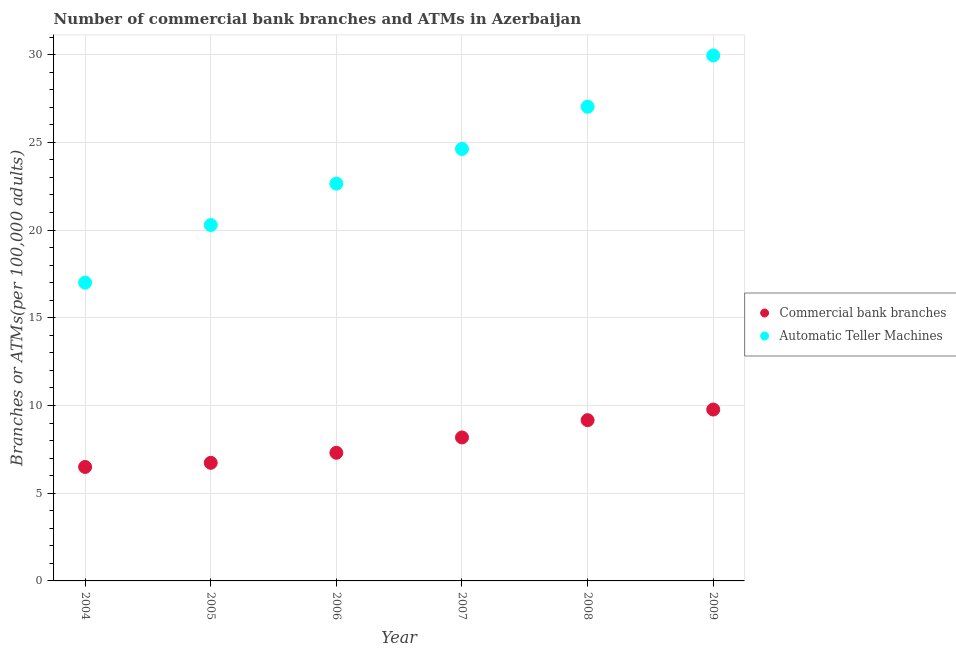Is the number of dotlines equal to the number of legend labels?
Ensure brevity in your answer.  Yes. What is the number of commercal bank branches in 2004?
Your response must be concise. 6.5. Across all years, what is the maximum number of atms?
Give a very brief answer. 29.95. Across all years, what is the minimum number of atms?
Your answer should be very brief. 17. In which year was the number of atms maximum?
Your answer should be compact. 2009. What is the total number of commercal bank branches in the graph?
Your answer should be very brief. 47.64. What is the difference between the number of commercal bank branches in 2005 and that in 2008?
Offer a very short reply. -2.43. What is the difference between the number of atms in 2008 and the number of commercal bank branches in 2004?
Keep it short and to the point. 20.53. What is the average number of atms per year?
Provide a short and direct response. 23.59. In the year 2009, what is the difference between the number of atms and number of commercal bank branches?
Give a very brief answer. 20.19. What is the ratio of the number of atms in 2008 to that in 2009?
Ensure brevity in your answer.  0.9. What is the difference between the highest and the second highest number of atms?
Your answer should be very brief. 2.92. What is the difference between the highest and the lowest number of commercal bank branches?
Give a very brief answer. 3.27. In how many years, is the number of commercal bank branches greater than the average number of commercal bank branches taken over all years?
Keep it short and to the point. 3. Is the sum of the number of atms in 2006 and 2008 greater than the maximum number of commercal bank branches across all years?
Keep it short and to the point. Yes. Does the number of atms monotonically increase over the years?
Provide a short and direct response. Yes. Is the number of commercal bank branches strictly greater than the number of atms over the years?
Keep it short and to the point. No. How many dotlines are there?
Offer a very short reply. 2. How many years are there in the graph?
Your answer should be very brief. 6. Are the values on the major ticks of Y-axis written in scientific E-notation?
Your response must be concise. No. Does the graph contain any zero values?
Provide a short and direct response. No. Does the graph contain grids?
Keep it short and to the point. Yes. Where does the legend appear in the graph?
Ensure brevity in your answer.  Center right. What is the title of the graph?
Provide a short and direct response. Number of commercial bank branches and ATMs in Azerbaijan. What is the label or title of the Y-axis?
Ensure brevity in your answer.  Branches or ATMs(per 100,0 adults). What is the Branches or ATMs(per 100,000 adults) in Commercial bank branches in 2004?
Your answer should be very brief. 6.5. What is the Branches or ATMs(per 100,000 adults) in Automatic Teller Machines in 2004?
Ensure brevity in your answer.  17. What is the Branches or ATMs(per 100,000 adults) of Commercial bank branches in 2005?
Offer a very short reply. 6.73. What is the Branches or ATMs(per 100,000 adults) of Automatic Teller Machines in 2005?
Provide a succinct answer. 20.29. What is the Branches or ATMs(per 100,000 adults) in Commercial bank branches in 2006?
Offer a terse response. 7.3. What is the Branches or ATMs(per 100,000 adults) in Automatic Teller Machines in 2006?
Your answer should be compact. 22.65. What is the Branches or ATMs(per 100,000 adults) of Commercial bank branches in 2007?
Provide a short and direct response. 8.18. What is the Branches or ATMs(per 100,000 adults) in Automatic Teller Machines in 2007?
Keep it short and to the point. 24.63. What is the Branches or ATMs(per 100,000 adults) in Commercial bank branches in 2008?
Your response must be concise. 9.16. What is the Branches or ATMs(per 100,000 adults) in Automatic Teller Machines in 2008?
Offer a terse response. 27.03. What is the Branches or ATMs(per 100,000 adults) of Commercial bank branches in 2009?
Offer a terse response. 9.77. What is the Branches or ATMs(per 100,000 adults) of Automatic Teller Machines in 2009?
Ensure brevity in your answer.  29.95. Across all years, what is the maximum Branches or ATMs(per 100,000 adults) of Commercial bank branches?
Keep it short and to the point. 9.77. Across all years, what is the maximum Branches or ATMs(per 100,000 adults) in Automatic Teller Machines?
Provide a succinct answer. 29.95. Across all years, what is the minimum Branches or ATMs(per 100,000 adults) of Commercial bank branches?
Keep it short and to the point. 6.5. Across all years, what is the minimum Branches or ATMs(per 100,000 adults) of Automatic Teller Machines?
Keep it short and to the point. 17. What is the total Branches or ATMs(per 100,000 adults) in Commercial bank branches in the graph?
Provide a short and direct response. 47.64. What is the total Branches or ATMs(per 100,000 adults) of Automatic Teller Machines in the graph?
Provide a short and direct response. 141.54. What is the difference between the Branches or ATMs(per 100,000 adults) of Commercial bank branches in 2004 and that in 2005?
Provide a succinct answer. -0.24. What is the difference between the Branches or ATMs(per 100,000 adults) in Automatic Teller Machines in 2004 and that in 2005?
Your response must be concise. -3.28. What is the difference between the Branches or ATMs(per 100,000 adults) in Commercial bank branches in 2004 and that in 2006?
Ensure brevity in your answer.  -0.81. What is the difference between the Branches or ATMs(per 100,000 adults) of Automatic Teller Machines in 2004 and that in 2006?
Offer a terse response. -5.65. What is the difference between the Branches or ATMs(per 100,000 adults) in Commercial bank branches in 2004 and that in 2007?
Your answer should be compact. -1.68. What is the difference between the Branches or ATMs(per 100,000 adults) in Automatic Teller Machines in 2004 and that in 2007?
Offer a terse response. -7.62. What is the difference between the Branches or ATMs(per 100,000 adults) in Commercial bank branches in 2004 and that in 2008?
Keep it short and to the point. -2.67. What is the difference between the Branches or ATMs(per 100,000 adults) of Automatic Teller Machines in 2004 and that in 2008?
Your answer should be compact. -10.03. What is the difference between the Branches or ATMs(per 100,000 adults) of Commercial bank branches in 2004 and that in 2009?
Offer a very short reply. -3.27. What is the difference between the Branches or ATMs(per 100,000 adults) in Automatic Teller Machines in 2004 and that in 2009?
Make the answer very short. -12.95. What is the difference between the Branches or ATMs(per 100,000 adults) in Commercial bank branches in 2005 and that in 2006?
Your response must be concise. -0.57. What is the difference between the Branches or ATMs(per 100,000 adults) of Automatic Teller Machines in 2005 and that in 2006?
Your response must be concise. -2.36. What is the difference between the Branches or ATMs(per 100,000 adults) of Commercial bank branches in 2005 and that in 2007?
Provide a succinct answer. -1.45. What is the difference between the Branches or ATMs(per 100,000 adults) of Automatic Teller Machines in 2005 and that in 2007?
Offer a very short reply. -4.34. What is the difference between the Branches or ATMs(per 100,000 adults) of Commercial bank branches in 2005 and that in 2008?
Ensure brevity in your answer.  -2.43. What is the difference between the Branches or ATMs(per 100,000 adults) of Automatic Teller Machines in 2005 and that in 2008?
Your response must be concise. -6.74. What is the difference between the Branches or ATMs(per 100,000 adults) of Commercial bank branches in 2005 and that in 2009?
Offer a very short reply. -3.04. What is the difference between the Branches or ATMs(per 100,000 adults) in Automatic Teller Machines in 2005 and that in 2009?
Offer a terse response. -9.67. What is the difference between the Branches or ATMs(per 100,000 adults) in Commercial bank branches in 2006 and that in 2007?
Your answer should be compact. -0.87. What is the difference between the Branches or ATMs(per 100,000 adults) in Automatic Teller Machines in 2006 and that in 2007?
Offer a terse response. -1.98. What is the difference between the Branches or ATMs(per 100,000 adults) in Commercial bank branches in 2006 and that in 2008?
Offer a very short reply. -1.86. What is the difference between the Branches or ATMs(per 100,000 adults) in Automatic Teller Machines in 2006 and that in 2008?
Give a very brief answer. -4.38. What is the difference between the Branches or ATMs(per 100,000 adults) of Commercial bank branches in 2006 and that in 2009?
Keep it short and to the point. -2.46. What is the difference between the Branches or ATMs(per 100,000 adults) in Automatic Teller Machines in 2006 and that in 2009?
Give a very brief answer. -7.31. What is the difference between the Branches or ATMs(per 100,000 adults) in Commercial bank branches in 2007 and that in 2008?
Provide a succinct answer. -0.98. What is the difference between the Branches or ATMs(per 100,000 adults) of Automatic Teller Machines in 2007 and that in 2008?
Keep it short and to the point. -2.41. What is the difference between the Branches or ATMs(per 100,000 adults) in Commercial bank branches in 2007 and that in 2009?
Provide a succinct answer. -1.59. What is the difference between the Branches or ATMs(per 100,000 adults) in Automatic Teller Machines in 2007 and that in 2009?
Your response must be concise. -5.33. What is the difference between the Branches or ATMs(per 100,000 adults) of Commercial bank branches in 2008 and that in 2009?
Provide a succinct answer. -0.6. What is the difference between the Branches or ATMs(per 100,000 adults) of Automatic Teller Machines in 2008 and that in 2009?
Offer a very short reply. -2.92. What is the difference between the Branches or ATMs(per 100,000 adults) in Commercial bank branches in 2004 and the Branches or ATMs(per 100,000 adults) in Automatic Teller Machines in 2005?
Provide a short and direct response. -13.79. What is the difference between the Branches or ATMs(per 100,000 adults) in Commercial bank branches in 2004 and the Branches or ATMs(per 100,000 adults) in Automatic Teller Machines in 2006?
Your answer should be very brief. -16.15. What is the difference between the Branches or ATMs(per 100,000 adults) in Commercial bank branches in 2004 and the Branches or ATMs(per 100,000 adults) in Automatic Teller Machines in 2007?
Offer a terse response. -18.13. What is the difference between the Branches or ATMs(per 100,000 adults) in Commercial bank branches in 2004 and the Branches or ATMs(per 100,000 adults) in Automatic Teller Machines in 2008?
Offer a very short reply. -20.53. What is the difference between the Branches or ATMs(per 100,000 adults) in Commercial bank branches in 2004 and the Branches or ATMs(per 100,000 adults) in Automatic Teller Machines in 2009?
Your answer should be compact. -23.46. What is the difference between the Branches or ATMs(per 100,000 adults) in Commercial bank branches in 2005 and the Branches or ATMs(per 100,000 adults) in Automatic Teller Machines in 2006?
Your response must be concise. -15.92. What is the difference between the Branches or ATMs(per 100,000 adults) of Commercial bank branches in 2005 and the Branches or ATMs(per 100,000 adults) of Automatic Teller Machines in 2007?
Make the answer very short. -17.89. What is the difference between the Branches or ATMs(per 100,000 adults) in Commercial bank branches in 2005 and the Branches or ATMs(per 100,000 adults) in Automatic Teller Machines in 2008?
Your response must be concise. -20.3. What is the difference between the Branches or ATMs(per 100,000 adults) in Commercial bank branches in 2005 and the Branches or ATMs(per 100,000 adults) in Automatic Teller Machines in 2009?
Give a very brief answer. -23.22. What is the difference between the Branches or ATMs(per 100,000 adults) of Commercial bank branches in 2006 and the Branches or ATMs(per 100,000 adults) of Automatic Teller Machines in 2007?
Provide a short and direct response. -17.32. What is the difference between the Branches or ATMs(per 100,000 adults) in Commercial bank branches in 2006 and the Branches or ATMs(per 100,000 adults) in Automatic Teller Machines in 2008?
Give a very brief answer. -19.73. What is the difference between the Branches or ATMs(per 100,000 adults) of Commercial bank branches in 2006 and the Branches or ATMs(per 100,000 adults) of Automatic Teller Machines in 2009?
Provide a short and direct response. -22.65. What is the difference between the Branches or ATMs(per 100,000 adults) in Commercial bank branches in 2007 and the Branches or ATMs(per 100,000 adults) in Automatic Teller Machines in 2008?
Give a very brief answer. -18.85. What is the difference between the Branches or ATMs(per 100,000 adults) of Commercial bank branches in 2007 and the Branches or ATMs(per 100,000 adults) of Automatic Teller Machines in 2009?
Ensure brevity in your answer.  -21.77. What is the difference between the Branches or ATMs(per 100,000 adults) of Commercial bank branches in 2008 and the Branches or ATMs(per 100,000 adults) of Automatic Teller Machines in 2009?
Offer a terse response. -20.79. What is the average Branches or ATMs(per 100,000 adults) of Commercial bank branches per year?
Keep it short and to the point. 7.94. What is the average Branches or ATMs(per 100,000 adults) of Automatic Teller Machines per year?
Ensure brevity in your answer.  23.59. In the year 2004, what is the difference between the Branches or ATMs(per 100,000 adults) of Commercial bank branches and Branches or ATMs(per 100,000 adults) of Automatic Teller Machines?
Your answer should be compact. -10.51. In the year 2005, what is the difference between the Branches or ATMs(per 100,000 adults) of Commercial bank branches and Branches or ATMs(per 100,000 adults) of Automatic Teller Machines?
Ensure brevity in your answer.  -13.55. In the year 2006, what is the difference between the Branches or ATMs(per 100,000 adults) of Commercial bank branches and Branches or ATMs(per 100,000 adults) of Automatic Teller Machines?
Offer a terse response. -15.34. In the year 2007, what is the difference between the Branches or ATMs(per 100,000 adults) of Commercial bank branches and Branches or ATMs(per 100,000 adults) of Automatic Teller Machines?
Provide a short and direct response. -16.45. In the year 2008, what is the difference between the Branches or ATMs(per 100,000 adults) of Commercial bank branches and Branches or ATMs(per 100,000 adults) of Automatic Teller Machines?
Your response must be concise. -17.87. In the year 2009, what is the difference between the Branches or ATMs(per 100,000 adults) in Commercial bank branches and Branches or ATMs(per 100,000 adults) in Automatic Teller Machines?
Your answer should be very brief. -20.19. What is the ratio of the Branches or ATMs(per 100,000 adults) in Commercial bank branches in 2004 to that in 2005?
Provide a succinct answer. 0.96. What is the ratio of the Branches or ATMs(per 100,000 adults) in Automatic Teller Machines in 2004 to that in 2005?
Ensure brevity in your answer.  0.84. What is the ratio of the Branches or ATMs(per 100,000 adults) of Commercial bank branches in 2004 to that in 2006?
Your answer should be compact. 0.89. What is the ratio of the Branches or ATMs(per 100,000 adults) in Automatic Teller Machines in 2004 to that in 2006?
Your response must be concise. 0.75. What is the ratio of the Branches or ATMs(per 100,000 adults) of Commercial bank branches in 2004 to that in 2007?
Give a very brief answer. 0.79. What is the ratio of the Branches or ATMs(per 100,000 adults) of Automatic Teller Machines in 2004 to that in 2007?
Keep it short and to the point. 0.69. What is the ratio of the Branches or ATMs(per 100,000 adults) in Commercial bank branches in 2004 to that in 2008?
Make the answer very short. 0.71. What is the ratio of the Branches or ATMs(per 100,000 adults) in Automatic Teller Machines in 2004 to that in 2008?
Keep it short and to the point. 0.63. What is the ratio of the Branches or ATMs(per 100,000 adults) of Commercial bank branches in 2004 to that in 2009?
Your response must be concise. 0.67. What is the ratio of the Branches or ATMs(per 100,000 adults) of Automatic Teller Machines in 2004 to that in 2009?
Provide a succinct answer. 0.57. What is the ratio of the Branches or ATMs(per 100,000 adults) of Commercial bank branches in 2005 to that in 2006?
Offer a terse response. 0.92. What is the ratio of the Branches or ATMs(per 100,000 adults) in Automatic Teller Machines in 2005 to that in 2006?
Keep it short and to the point. 0.9. What is the ratio of the Branches or ATMs(per 100,000 adults) of Commercial bank branches in 2005 to that in 2007?
Keep it short and to the point. 0.82. What is the ratio of the Branches or ATMs(per 100,000 adults) of Automatic Teller Machines in 2005 to that in 2007?
Give a very brief answer. 0.82. What is the ratio of the Branches or ATMs(per 100,000 adults) of Commercial bank branches in 2005 to that in 2008?
Keep it short and to the point. 0.73. What is the ratio of the Branches or ATMs(per 100,000 adults) of Automatic Teller Machines in 2005 to that in 2008?
Keep it short and to the point. 0.75. What is the ratio of the Branches or ATMs(per 100,000 adults) in Commercial bank branches in 2005 to that in 2009?
Keep it short and to the point. 0.69. What is the ratio of the Branches or ATMs(per 100,000 adults) in Automatic Teller Machines in 2005 to that in 2009?
Offer a very short reply. 0.68. What is the ratio of the Branches or ATMs(per 100,000 adults) in Commercial bank branches in 2006 to that in 2007?
Ensure brevity in your answer.  0.89. What is the ratio of the Branches or ATMs(per 100,000 adults) in Automatic Teller Machines in 2006 to that in 2007?
Your answer should be very brief. 0.92. What is the ratio of the Branches or ATMs(per 100,000 adults) of Commercial bank branches in 2006 to that in 2008?
Offer a very short reply. 0.8. What is the ratio of the Branches or ATMs(per 100,000 adults) in Automatic Teller Machines in 2006 to that in 2008?
Ensure brevity in your answer.  0.84. What is the ratio of the Branches or ATMs(per 100,000 adults) in Commercial bank branches in 2006 to that in 2009?
Your response must be concise. 0.75. What is the ratio of the Branches or ATMs(per 100,000 adults) in Automatic Teller Machines in 2006 to that in 2009?
Offer a very short reply. 0.76. What is the ratio of the Branches or ATMs(per 100,000 adults) in Commercial bank branches in 2007 to that in 2008?
Make the answer very short. 0.89. What is the ratio of the Branches or ATMs(per 100,000 adults) in Automatic Teller Machines in 2007 to that in 2008?
Keep it short and to the point. 0.91. What is the ratio of the Branches or ATMs(per 100,000 adults) of Commercial bank branches in 2007 to that in 2009?
Provide a succinct answer. 0.84. What is the ratio of the Branches or ATMs(per 100,000 adults) of Automatic Teller Machines in 2007 to that in 2009?
Make the answer very short. 0.82. What is the ratio of the Branches or ATMs(per 100,000 adults) of Commercial bank branches in 2008 to that in 2009?
Offer a terse response. 0.94. What is the ratio of the Branches or ATMs(per 100,000 adults) of Automatic Teller Machines in 2008 to that in 2009?
Keep it short and to the point. 0.9. What is the difference between the highest and the second highest Branches or ATMs(per 100,000 adults) in Commercial bank branches?
Your response must be concise. 0.6. What is the difference between the highest and the second highest Branches or ATMs(per 100,000 adults) of Automatic Teller Machines?
Keep it short and to the point. 2.92. What is the difference between the highest and the lowest Branches or ATMs(per 100,000 adults) of Commercial bank branches?
Offer a very short reply. 3.27. What is the difference between the highest and the lowest Branches or ATMs(per 100,000 adults) of Automatic Teller Machines?
Your answer should be very brief. 12.95. 